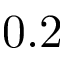<formula> <loc_0><loc_0><loc_500><loc_500>0 . 2</formula> 